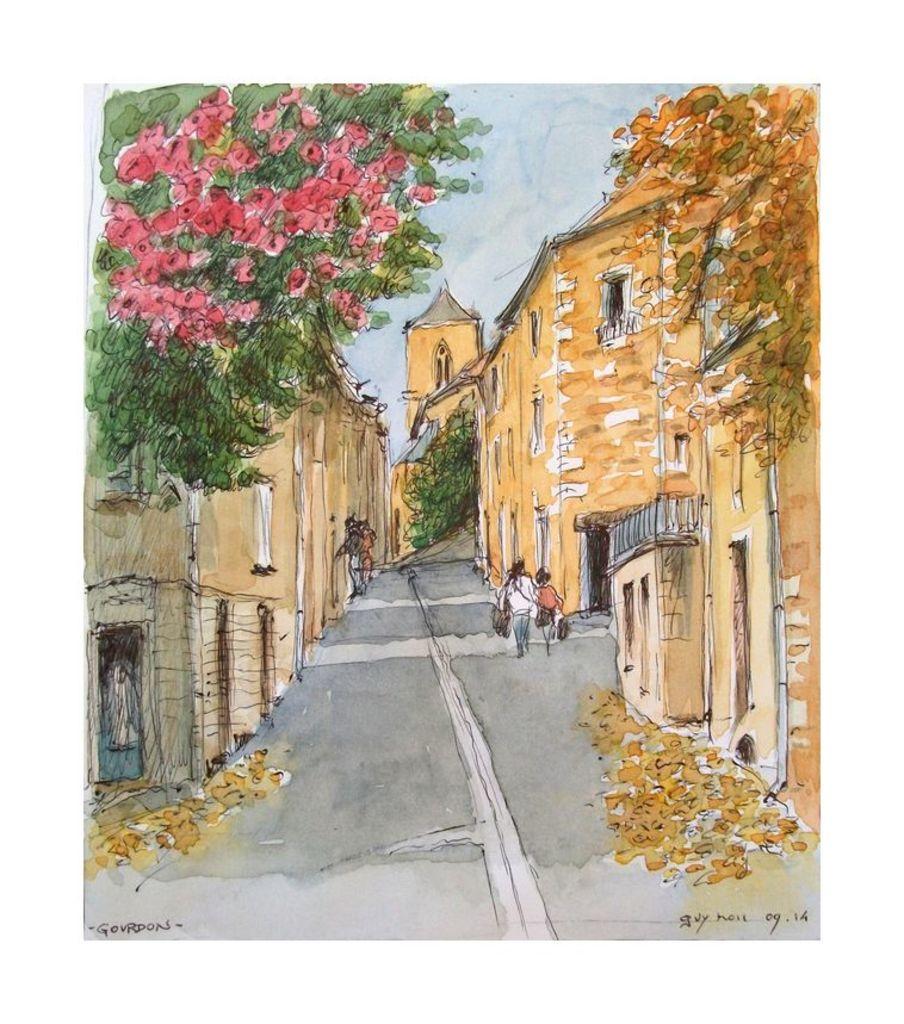How would you summarize this image in a sentence or two? In this image we can see a painting in which we can see group of people standing, buildings with windows, flowers, some trees and the sky. 